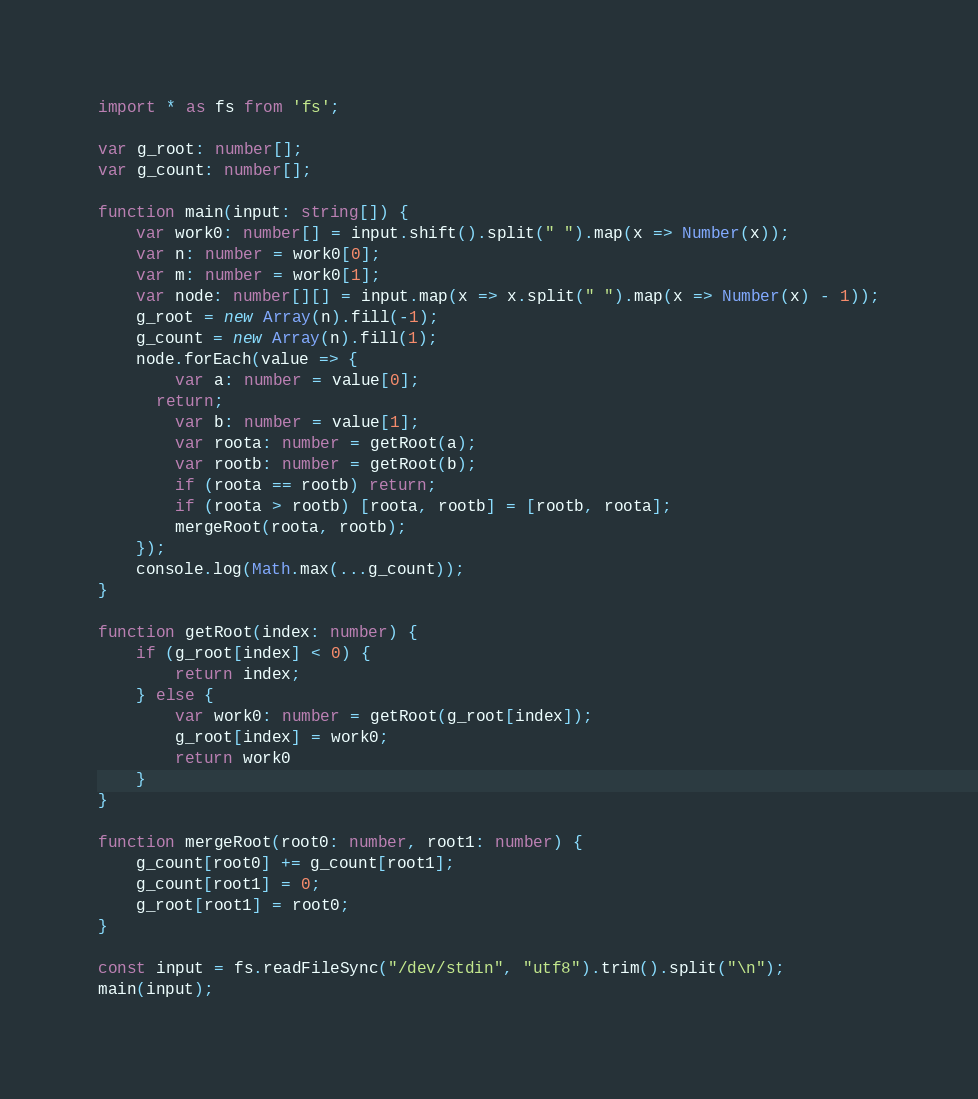<code> <loc_0><loc_0><loc_500><loc_500><_TypeScript_>import * as fs from 'fs';

var g_root: number[];
var g_count: number[];

function main(input: string[]) {
	var work0: number[] = input.shift().split(" ").map(x => Number(x));
	var n: number = work0[0];
	var m: number = work0[1];
	var node: number[][] = input.map(x => x.split(" ").map(x => Number(x) - 1));
	g_root = new Array(n).fill(-1);
	g_count = new Array(n).fill(1);
	node.forEach(value => {
		var a: number = value[0];
      return;
		var b: number = value[1];
		var roota: number = getRoot(a);
		var rootb: number = getRoot(b);
		if (roota == rootb) return;
		if (roota > rootb) [roota, rootb] = [rootb, roota];
		mergeRoot(roota, rootb);
	});
	console.log(Math.max(...g_count));
}

function getRoot(index: number) {
	if (g_root[index] < 0) {
		return index;
	} else {
		var work0: number = getRoot(g_root[index]);
		g_root[index] = work0;
		return work0
	}
}

function mergeRoot(root0: number, root1: number) {
	g_count[root0] += g_count[root1];
	g_count[root1] = 0;
	g_root[root1] = root0;
}

const input = fs.readFileSync("/dev/stdin", "utf8").trim().split("\n");
main(input);
</code> 